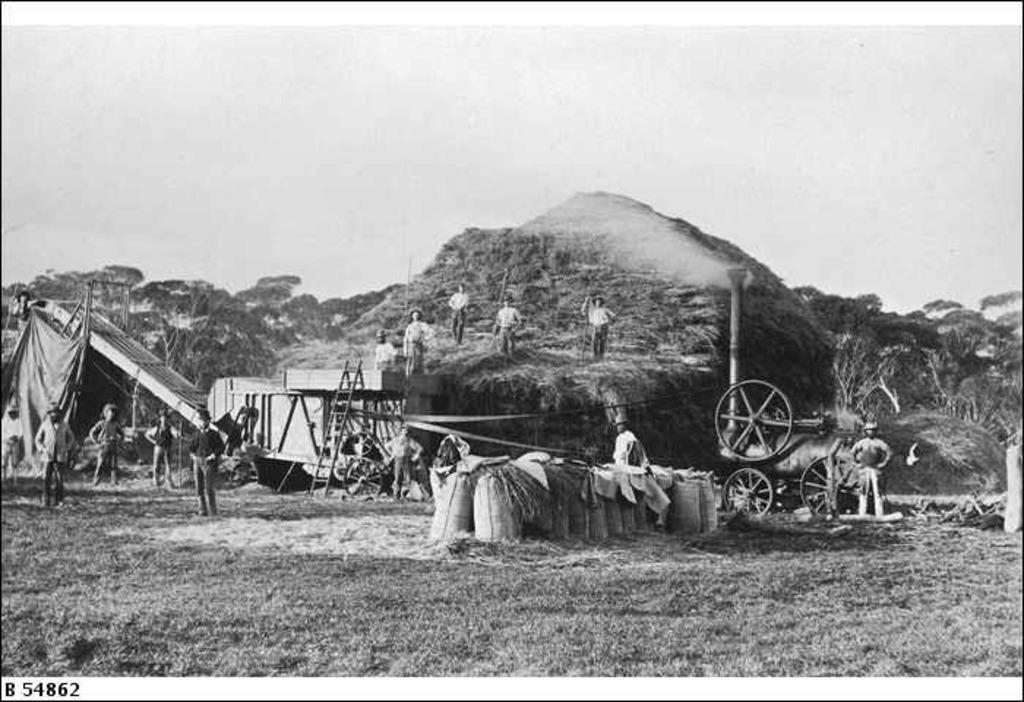Could you give a brief overview of what you see in this image? This is a black and white image. In the center of the image we can see a heap of grass and some people are standing on it and holding the sticks. In the background of the image we can see the trees, ladder, wheels, gunny bags, cloth and some people are standing. At the bottom of the image we can see the ground. At the top of the image we can see the sky. In the bottom left corner we can see the numbers. 